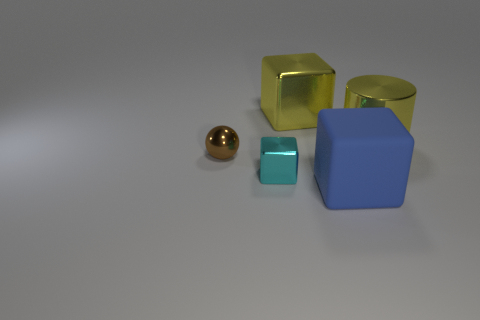How many other objects are the same shape as the tiny brown object?
Give a very brief answer. 0. The matte cube is what color?
Ensure brevity in your answer.  Blue. Is the shiny cylinder the same color as the tiny shiny ball?
Offer a very short reply. No. Are the big yellow thing to the left of the big cylinder and the big object in front of the small brown shiny ball made of the same material?
Your response must be concise. No. There is a blue object that is the same shape as the cyan metal thing; what is its material?
Provide a succinct answer. Rubber. Is the material of the tiny brown ball the same as the cyan thing?
Offer a terse response. Yes. There is a large cube that is on the left side of the large blue thing in front of the big yellow cylinder; what color is it?
Offer a very short reply. Yellow. What is the size of the cyan thing that is the same material as the cylinder?
Ensure brevity in your answer.  Small. How many big blue objects have the same shape as the small cyan thing?
Give a very brief answer. 1. How many objects are either objects in front of the large yellow cube or small metal things in front of the tiny brown metal ball?
Your answer should be very brief. 4. 